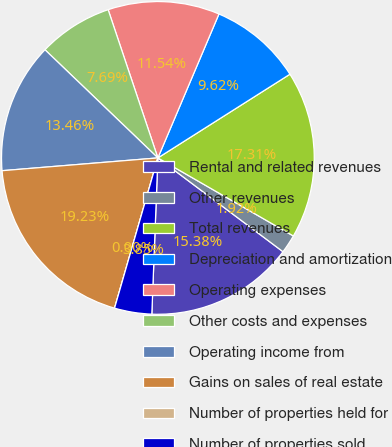Convert chart to OTSL. <chart><loc_0><loc_0><loc_500><loc_500><pie_chart><fcel>Rental and related revenues<fcel>Other revenues<fcel>Total revenues<fcel>Depreciation and amortization<fcel>Operating expenses<fcel>Other costs and expenses<fcel>Operating income from<fcel>Gains on sales of real estate<fcel>Number of properties held for<fcel>Number of properties sold<nl><fcel>15.38%<fcel>1.92%<fcel>17.31%<fcel>9.62%<fcel>11.54%<fcel>7.69%<fcel>13.46%<fcel>19.23%<fcel>0.0%<fcel>3.85%<nl></chart> 